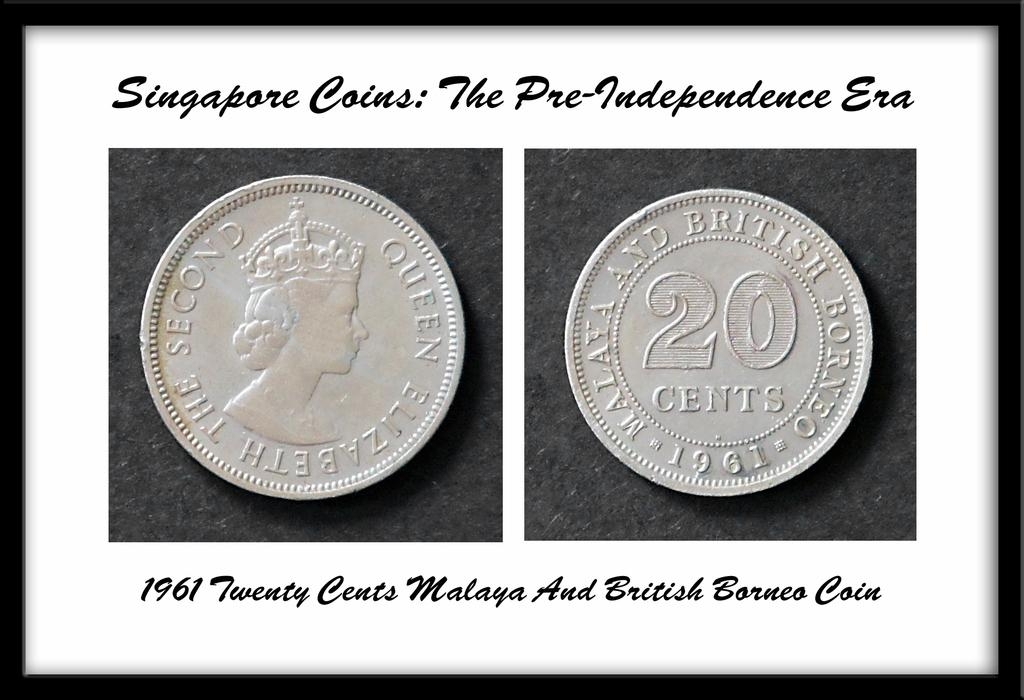<image>
Share a concise interpretation of the image provided. Silver round coin dated from 1961 and British 